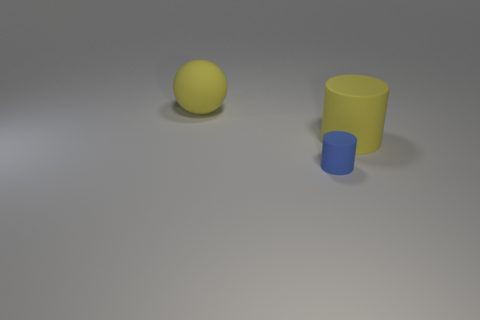Is the number of big yellow balls less than the number of tiny cyan matte things? no 